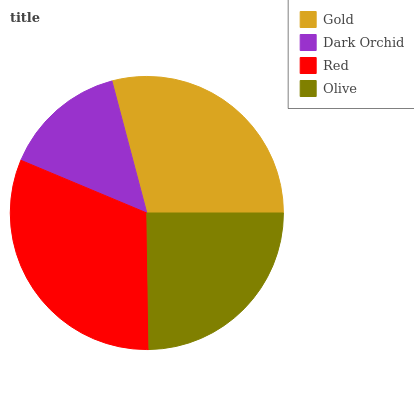Is Dark Orchid the minimum?
Answer yes or no. Yes. Is Red the maximum?
Answer yes or no. Yes. Is Red the minimum?
Answer yes or no. No. Is Dark Orchid the maximum?
Answer yes or no. No. Is Red greater than Dark Orchid?
Answer yes or no. Yes. Is Dark Orchid less than Red?
Answer yes or no. Yes. Is Dark Orchid greater than Red?
Answer yes or no. No. Is Red less than Dark Orchid?
Answer yes or no. No. Is Gold the high median?
Answer yes or no. Yes. Is Olive the low median?
Answer yes or no. Yes. Is Olive the high median?
Answer yes or no. No. Is Gold the low median?
Answer yes or no. No. 